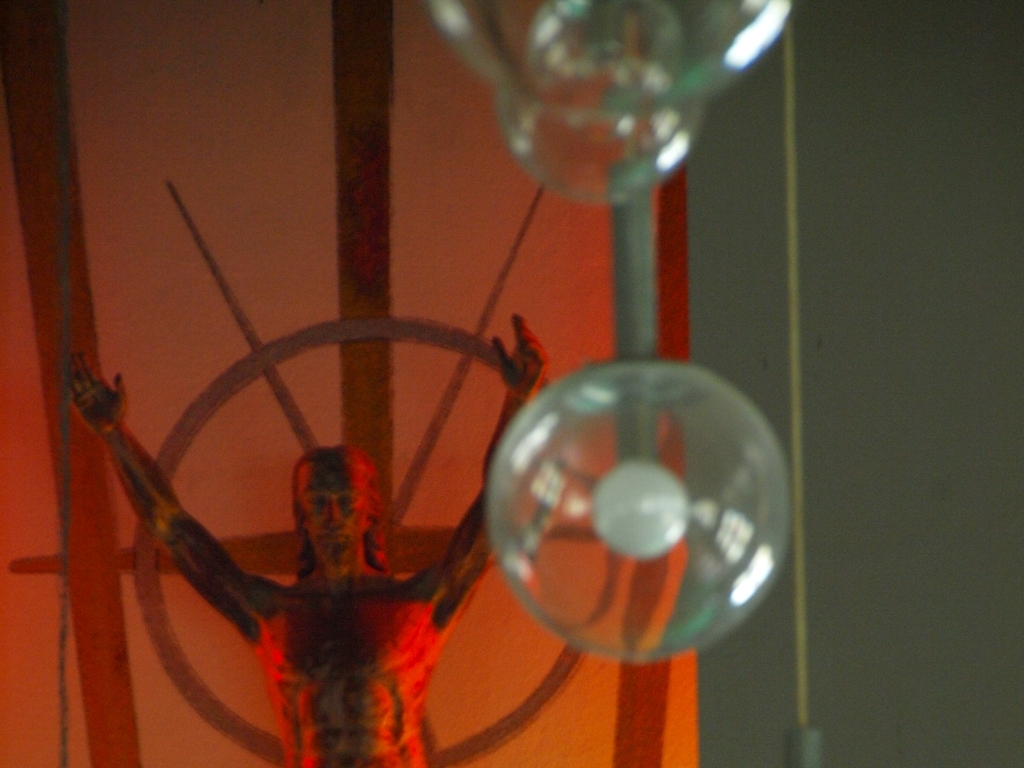What does the inclusion of transparent spheres around the sculpture suggest? The transparent spheres create a visual juxtaposition against the stark, rigid form of the sculpture. They might represent purity, fragility, or the idea of encapsulation. Their positioning could be interpreted as orbiting the figure, suggesting a cosmic or metaphysical dimension to the sculpture's theme. Is there any significance to the way the sculpture interacts with its surrounding space? The sculpture's interaction with its space is quite intriguing. It appears to almost pierce through the surroundings with its pronounced gesture and halo, disrupting the otherwise ordinary environment. This dynamic could signify an intrusion of the extraordinary into the mundane or evoke a sense of a breaking free from constraints. 